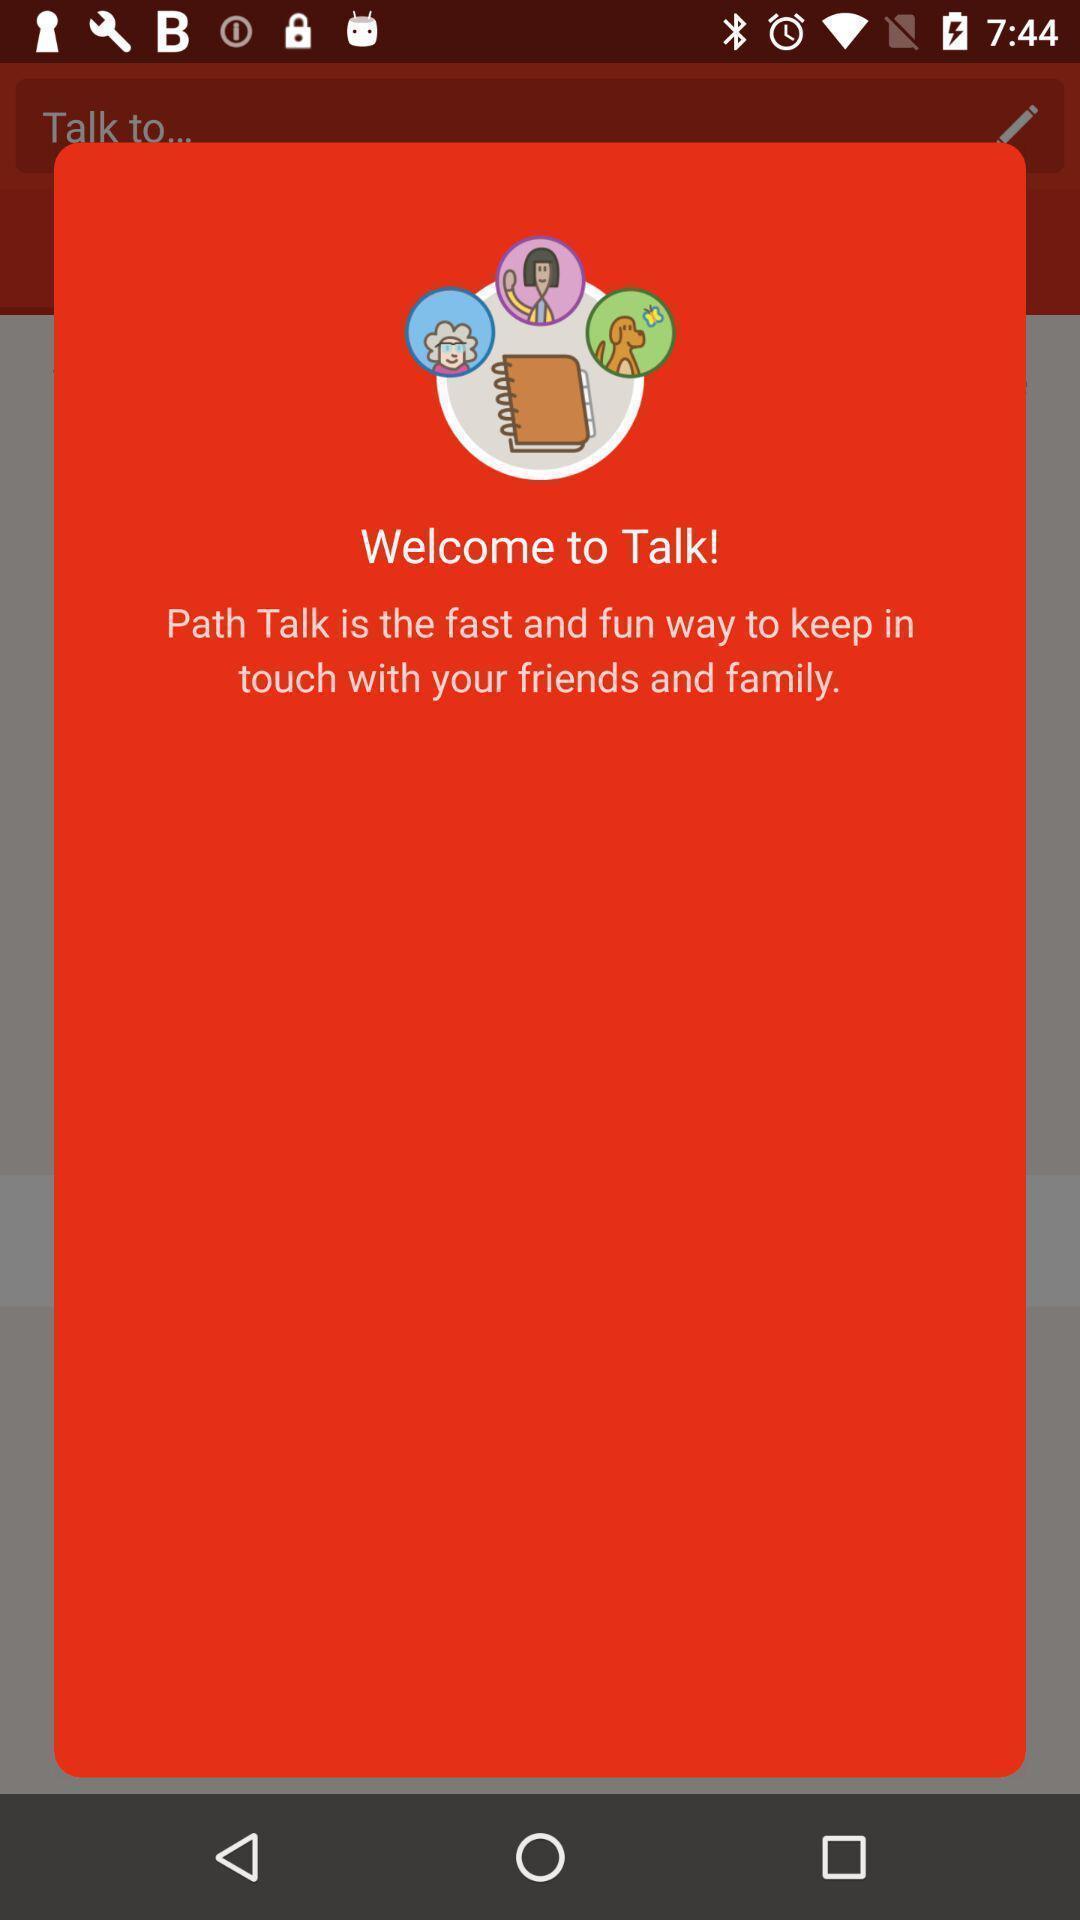Describe the visual elements of this screenshot. Welcome page of social app. 